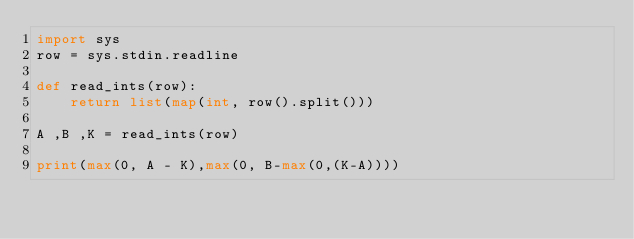Convert code to text. <code><loc_0><loc_0><loc_500><loc_500><_Python_>import sys
row = sys.stdin.readline
 
def read_ints(row):
    return list(map(int, row().split()))
  
A ,B ,K = read_ints(row)
 
print(max(0, A - K),max(0, B-max(0,(K-A))))</code> 